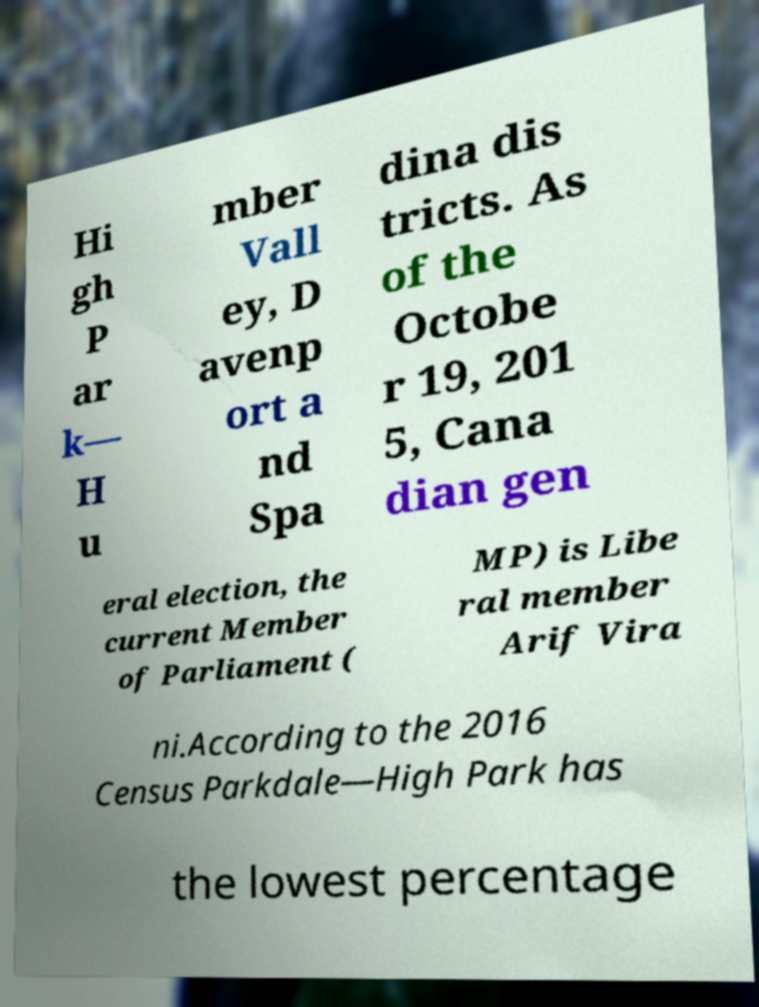Could you extract and type out the text from this image? Hi gh P ar k— H u mber Vall ey, D avenp ort a nd Spa dina dis tricts. As of the Octobe r 19, 201 5, Cana dian gen eral election, the current Member of Parliament ( MP) is Libe ral member Arif Vira ni.According to the 2016 Census Parkdale—High Park has the lowest percentage 